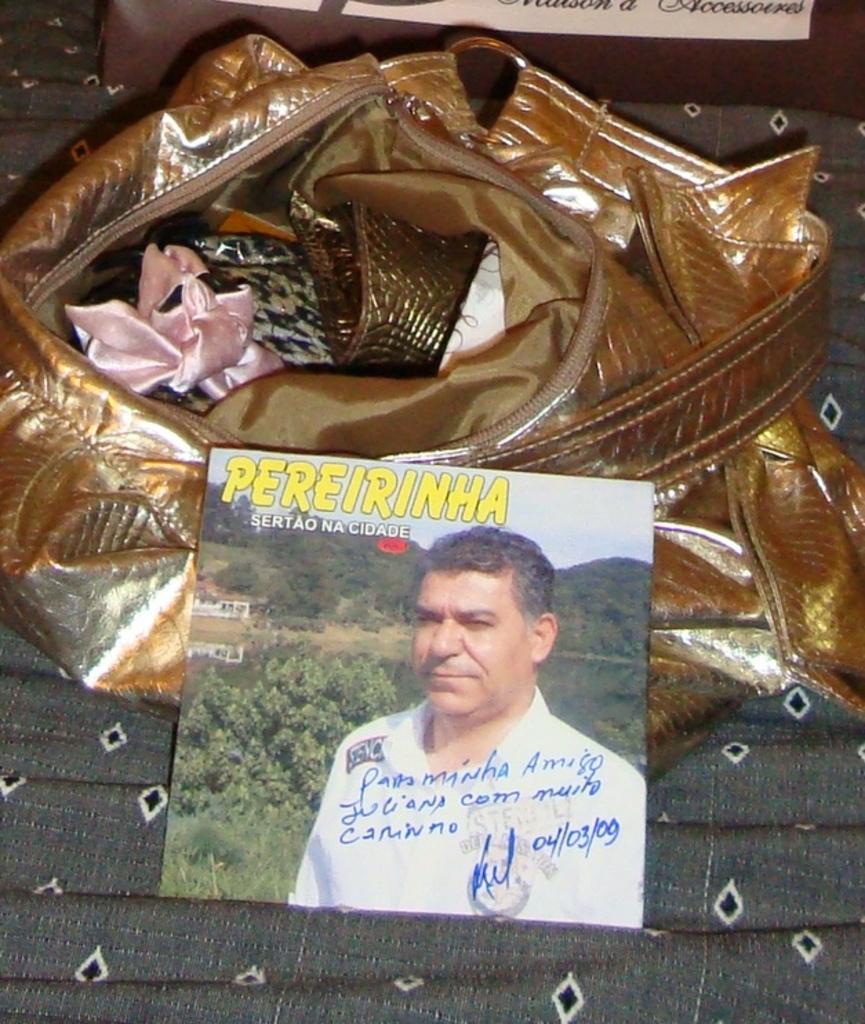Please provide a concise description of this image. In this image there is a purse in golden brown. Before that there is a photo of a person, he wears a white shirt. In the photo there is a background of trees and house. 